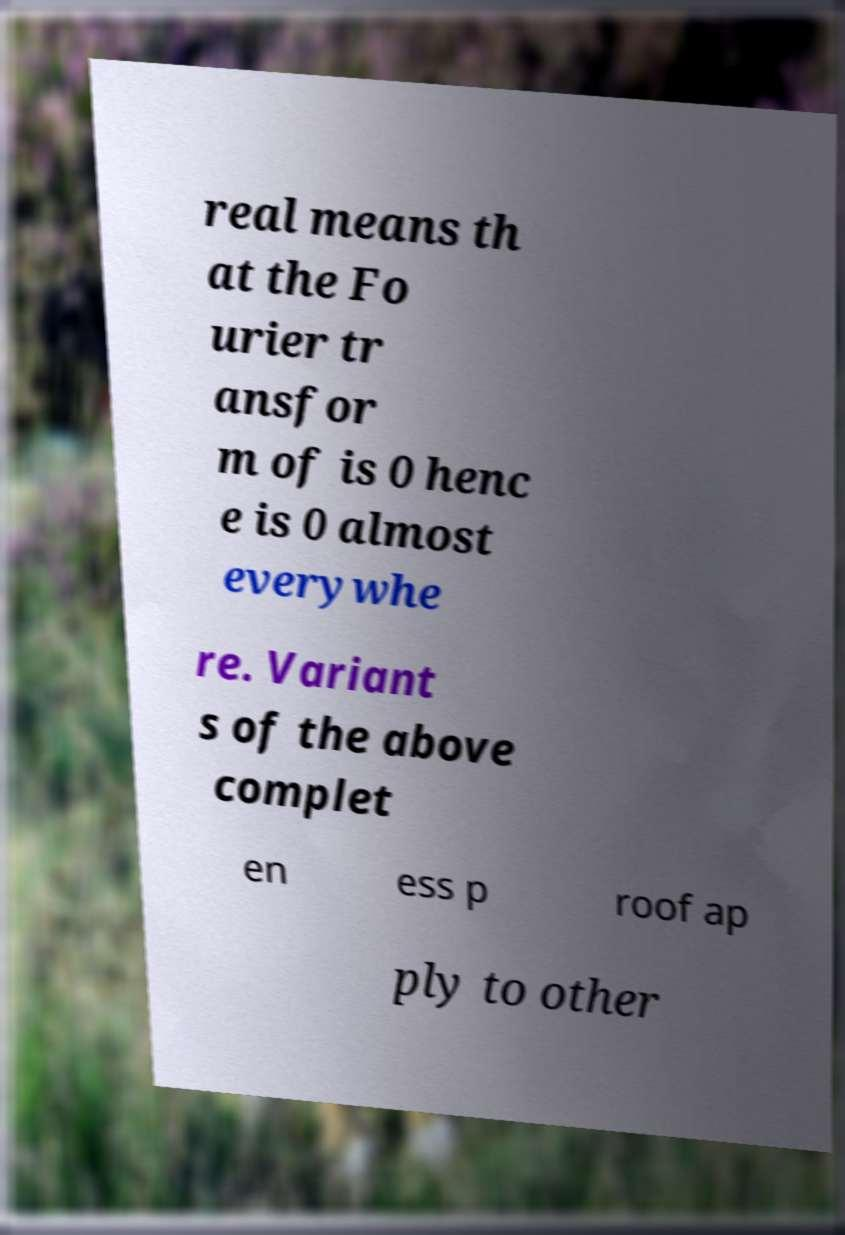What messages or text are displayed in this image? I need them in a readable, typed format. real means th at the Fo urier tr ansfor m of is 0 henc e is 0 almost everywhe re. Variant s of the above complet en ess p roof ap ply to other 